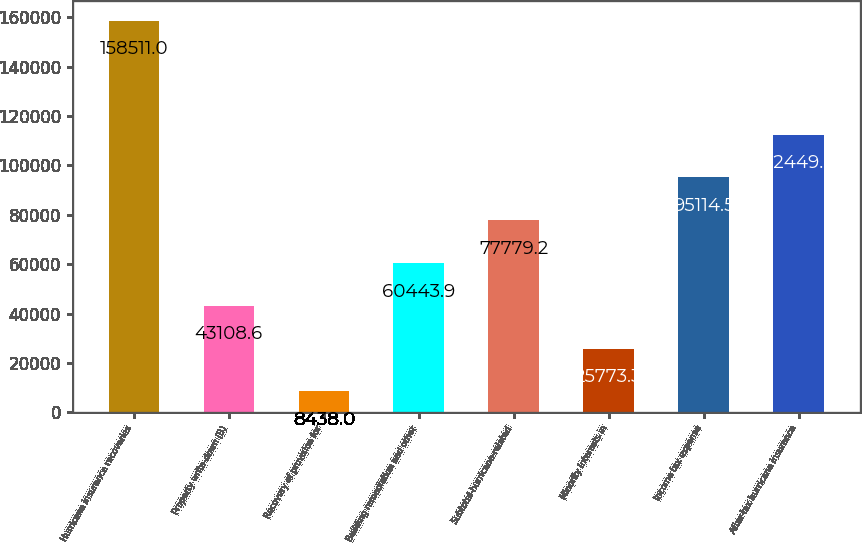Convert chart to OTSL. <chart><loc_0><loc_0><loc_500><loc_500><bar_chart><fcel>Hurricane insurance recoveries<fcel>Property write-down (B)<fcel>Recovery of provision for<fcel>Building remediation and other<fcel>Subtotal-hurricane-related<fcel>Minority interests in<fcel>Income tax expense<fcel>After-tax hurricane insurance<nl><fcel>158511<fcel>43108.6<fcel>8438<fcel>60443.9<fcel>77779.2<fcel>25773.3<fcel>95114.5<fcel>112450<nl></chart> 